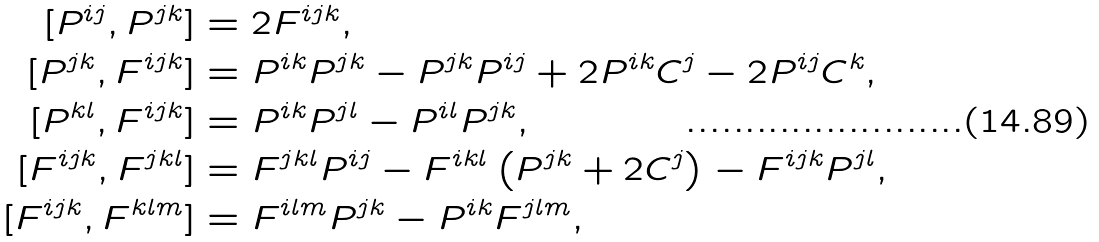Convert formula to latex. <formula><loc_0><loc_0><loc_500><loc_500>[ P ^ { i j } , P ^ { j k } ] & = 2 F ^ { i j k } , \\ [ P ^ { j k } , F ^ { i j k } ] & = P ^ { i k } P ^ { j k } - P ^ { j k } P ^ { i j } + 2 P ^ { i k } C ^ { j } - 2 P ^ { i j } C ^ { k } , \\ [ P ^ { k l } , F ^ { i j k } ] & = P ^ { i k } P ^ { j l } - P ^ { i l } P ^ { j k } , \\ [ F ^ { i j k } , F ^ { j k l } ] & = F ^ { j k l } P ^ { i j } - F ^ { i k l } \left ( P ^ { j k } + 2 C ^ { j } \right ) - F ^ { i j k } P ^ { j l } , \\ [ F ^ { i j k } , F ^ { k l m } ] & = F ^ { i l m } P ^ { j k } - P ^ { i k } F ^ { j l m } ,</formula> 